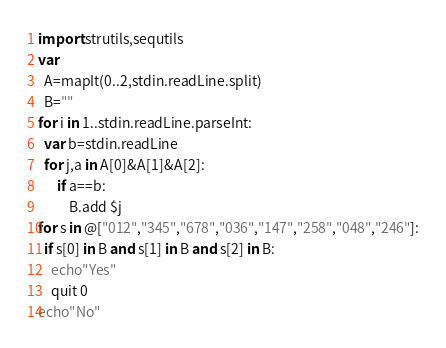Convert code to text. <code><loc_0><loc_0><loc_500><loc_500><_Nim_>import strutils,sequtils
var
  A=mapIt(0..2,stdin.readLine.split)
  B=""
for i in 1..stdin.readLine.parseInt:
  var b=stdin.readLine
  for j,a in A[0]&A[1]&A[2]:
      if a==b:
          B.add $j
for s in @["012","345","678","036","147","258","048","246"]:
  if s[0] in B and s[1] in B and s[2] in B:
    echo"Yes"
    quit 0
echo"No"</code> 